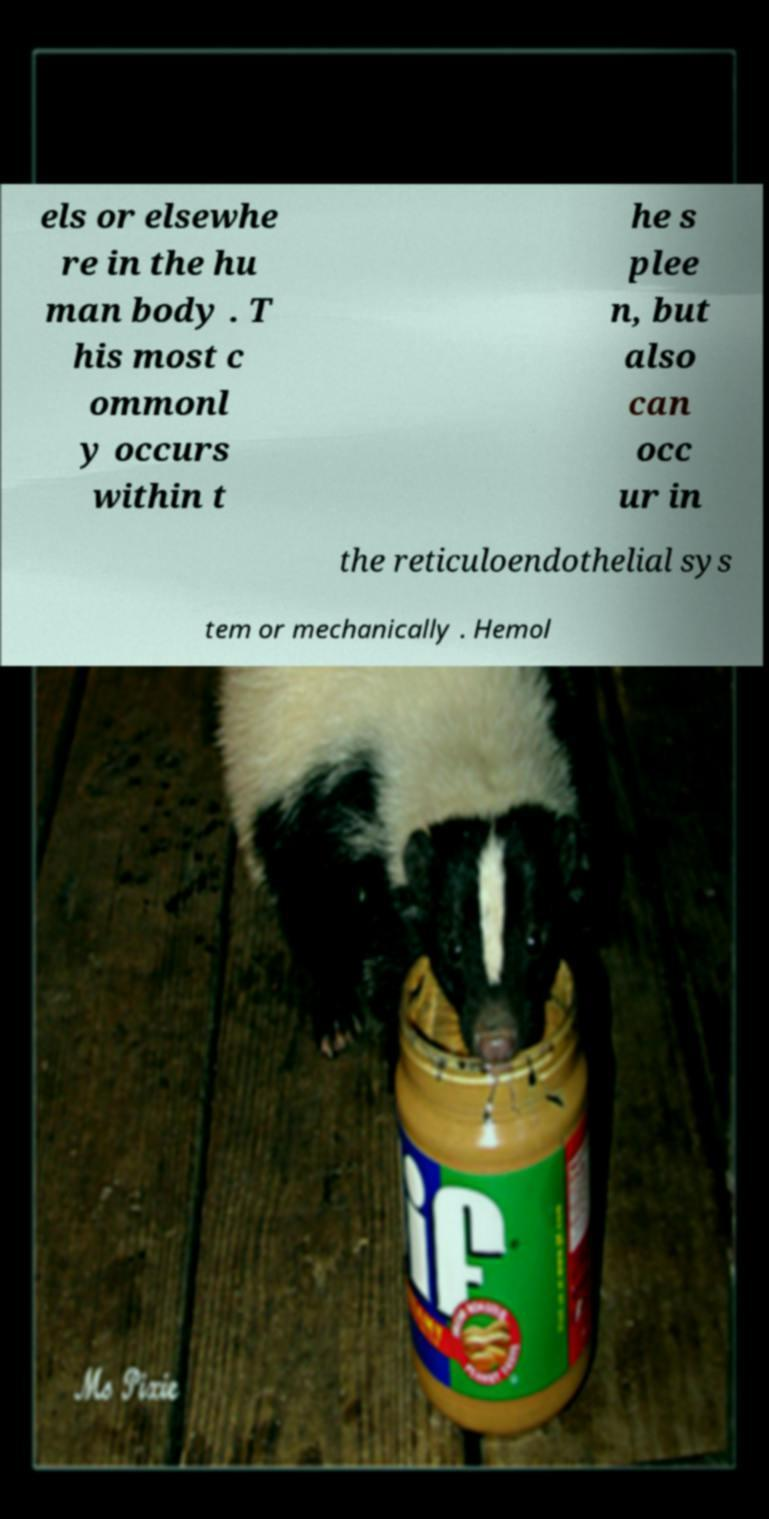Please identify and transcribe the text found in this image. els or elsewhe re in the hu man body . T his most c ommonl y occurs within t he s plee n, but also can occ ur in the reticuloendothelial sys tem or mechanically . Hemol 